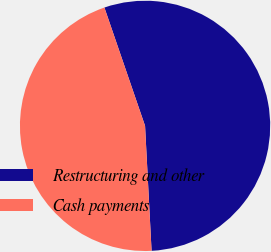Convert chart. <chart><loc_0><loc_0><loc_500><loc_500><pie_chart><fcel>Restructuring and other<fcel>Cash payments<nl><fcel>54.44%<fcel>45.56%<nl></chart> 